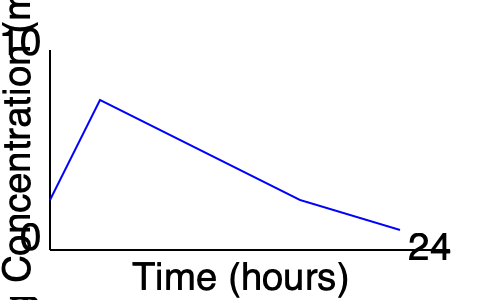Given the graph showing the concentration of a medication over 24 hours, what is the estimated half-life of the drug, assuming first-order kinetics? Explain your reasoning and calculations. To estimate the half-life of the drug, we need to follow these steps:

1. Identify the peak concentration and the time it occurs:
   From the graph, the peak concentration appears to be around 9 mg/L at approximately 4 hours.

2. Find a point on the descending portion of the curve:
   Let's choose the point at 16 hours, where the concentration is about 4.5 mg/L.

3. Use the first-order kinetics equation:
   $C_t = C_0 \cdot e^{-kt}$
   Where:
   $C_t$ is the concentration at time t
   $C_0$ is the initial concentration
   $k$ is the elimination rate constant
   $t$ is the time elapsed

4. Calculate the elimination rate constant (k):
   $4.5 = 9 \cdot e^{-k(16-4)}$
   $\ln(4.5/9) = -12k$
   $k = -\ln(0.5) / 12 \approx 0.0578 \text{ hr}^{-1}$

5. Calculate the half-life using the formula:
   $t_{1/2} = \ln(2) / k$
   $t_{1/2} = \ln(2) / 0.0578 \approx 12 \text{ hours}$

Therefore, the estimated half-life of the drug is approximately 12 hours.
Answer: 12 hours 